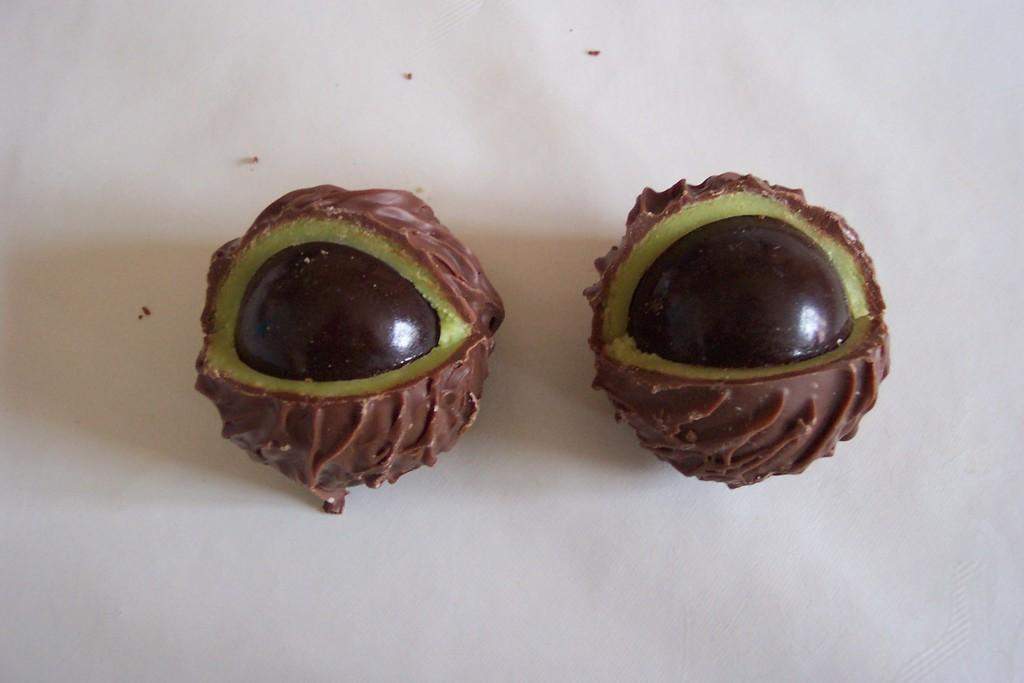What type of food items are present in the image? There are two chocolate items in the image. Can you describe the colors of the chocolate items? The chocolate items are in brown and green colors. What is the background or surface on which the chocolate items are placed? The chocolate items are on a white surface. How many chairs can be seen in the image? There are no chairs present in the image. Is there a carpenter working on the chocolate items in the image? There is no carpenter or any indication of work being done on the chocolate items in the image. 